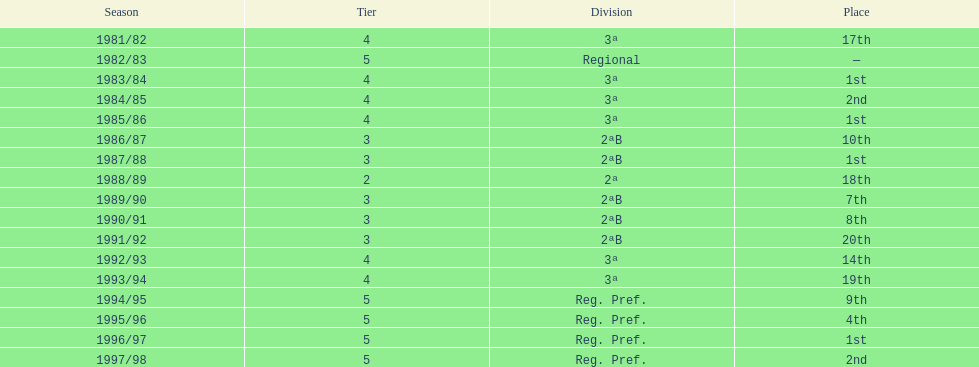What is the most recent year the team participated in division 2? 1991/92. 